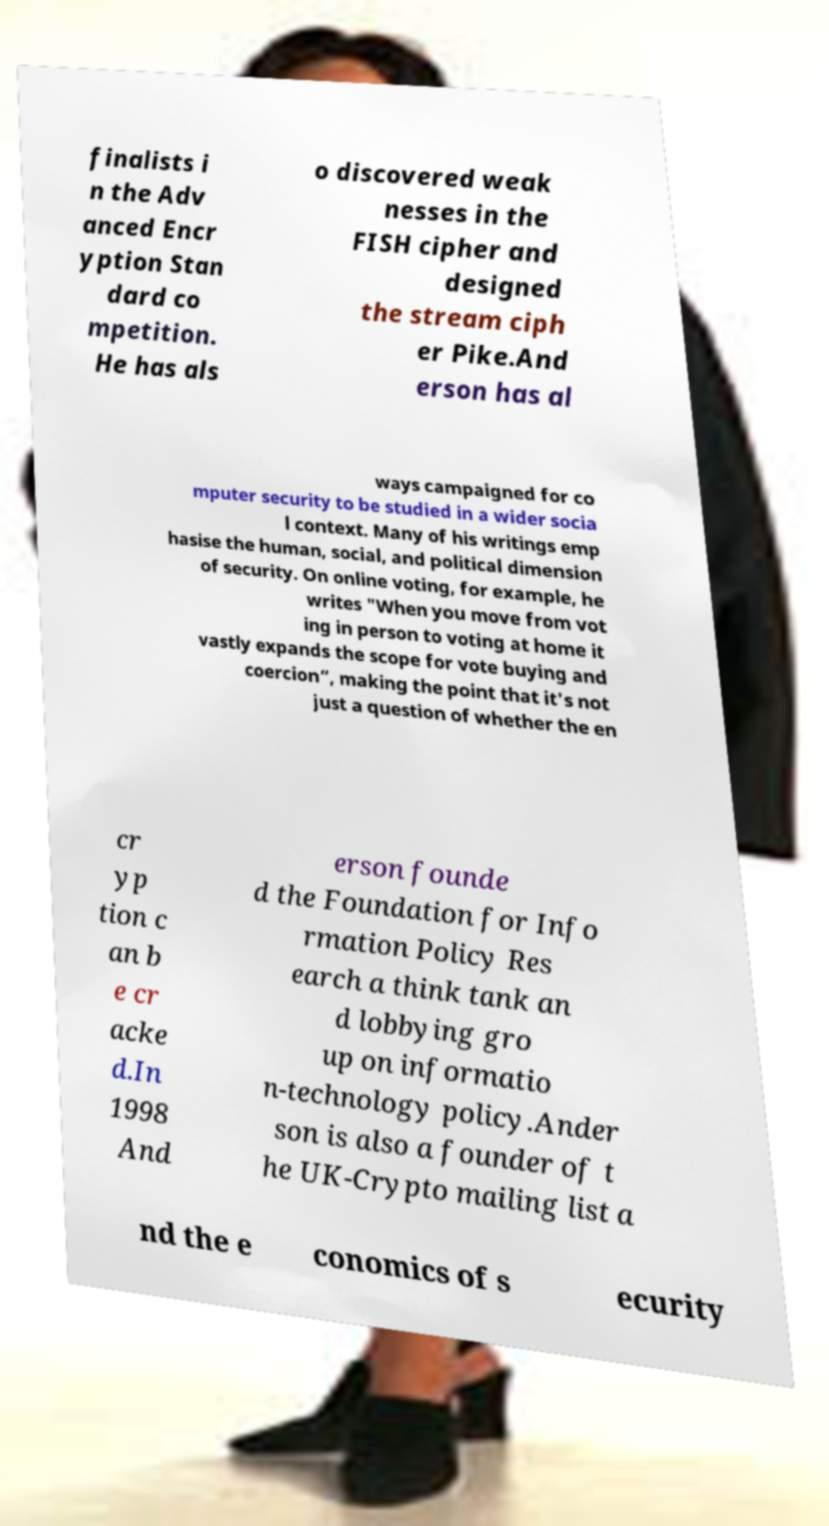Could you extract and type out the text from this image? finalists i n the Adv anced Encr yption Stan dard co mpetition. He has als o discovered weak nesses in the FISH cipher and designed the stream ciph er Pike.And erson has al ways campaigned for co mputer security to be studied in a wider socia l context. Many of his writings emp hasise the human, social, and political dimension of security. On online voting, for example, he writes "When you move from vot ing in person to voting at home it vastly expands the scope for vote buying and coercion”, making the point that it's not just a question of whether the en cr yp tion c an b e cr acke d.In 1998 And erson founde d the Foundation for Info rmation Policy Res earch a think tank an d lobbying gro up on informatio n-technology policy.Ander son is also a founder of t he UK-Crypto mailing list a nd the e conomics of s ecurity 